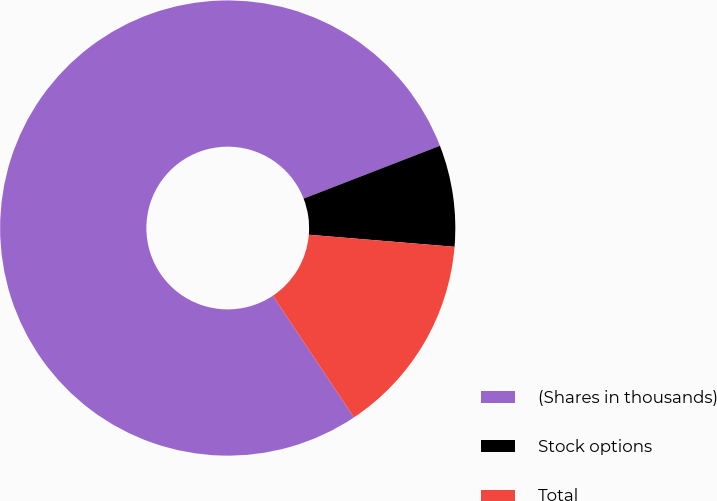Convert chart to OTSL. <chart><loc_0><loc_0><loc_500><loc_500><pie_chart><fcel>(Shares in thousands)<fcel>Stock options<fcel>Total<nl><fcel>78.47%<fcel>7.2%<fcel>14.33%<nl></chart> 